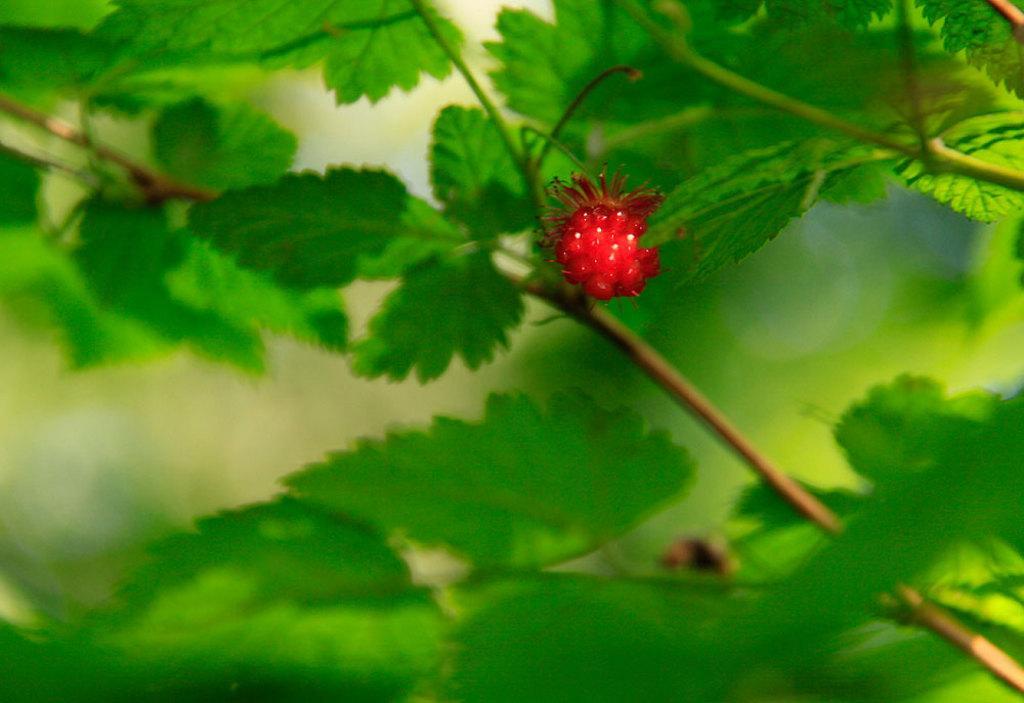Describe this image in one or two sentences. In this picture we can see the leaves and fruit. In the background, the image is blur. 